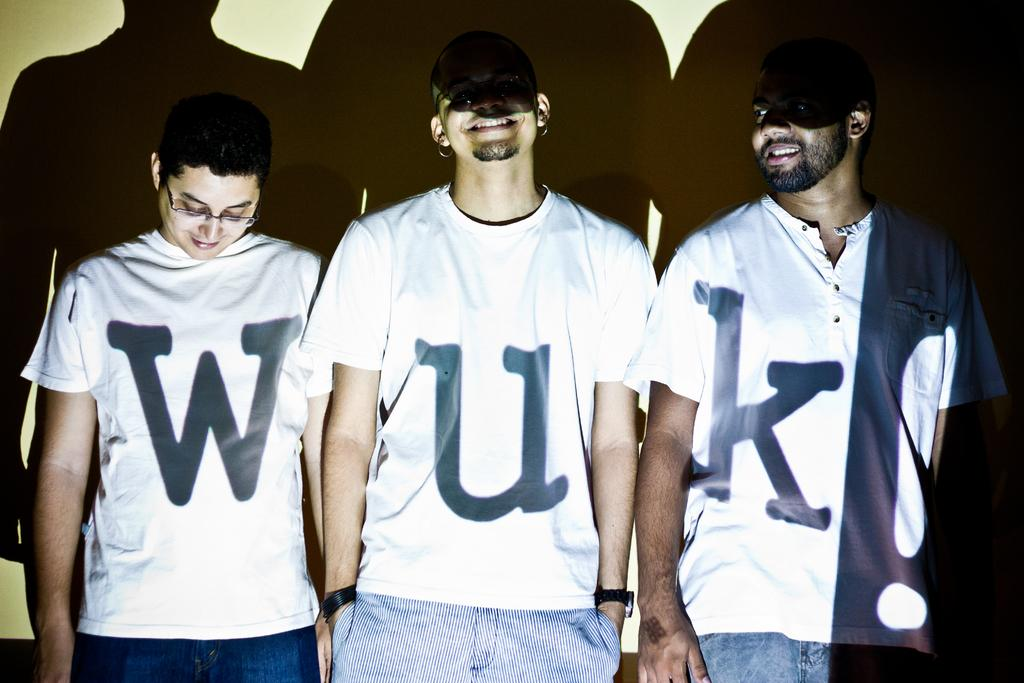<image>
Describe the image concisely. Three people standing together to spell the name WUK. 